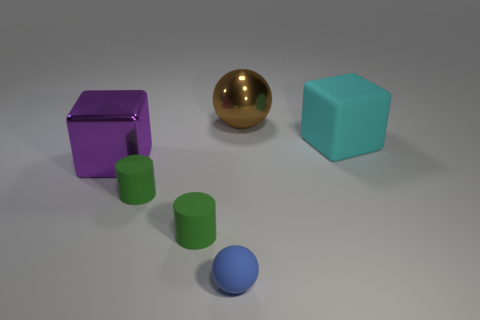Are there any other things that have the same color as the tiny ball?
Provide a succinct answer. No. What is the shape of the other large object that is the same material as the large brown thing?
Keep it short and to the point. Cube. There is a big shiny object right of the metallic object in front of the large metallic object that is right of the purple metal object; what is its color?
Keep it short and to the point. Brown. Are there the same number of large rubber things behind the large cyan rubber object and big shiny balls?
Provide a short and direct response. No. Are there any other things that are the same material as the big brown sphere?
Ensure brevity in your answer.  Yes. There is a large metallic cube; does it have the same color as the thing that is behind the cyan rubber thing?
Offer a very short reply. No. Is there a brown ball behind the large thing behind the cube that is on the right side of the big brown metal thing?
Make the answer very short. No. Are there fewer brown balls to the left of the tiny blue rubber sphere than tiny gray matte blocks?
Your response must be concise. No. How many other things are the same shape as the brown object?
Your answer should be very brief. 1. How many objects are things that are to the left of the rubber block or large metallic things that are in front of the big rubber cube?
Provide a succinct answer. 5. 